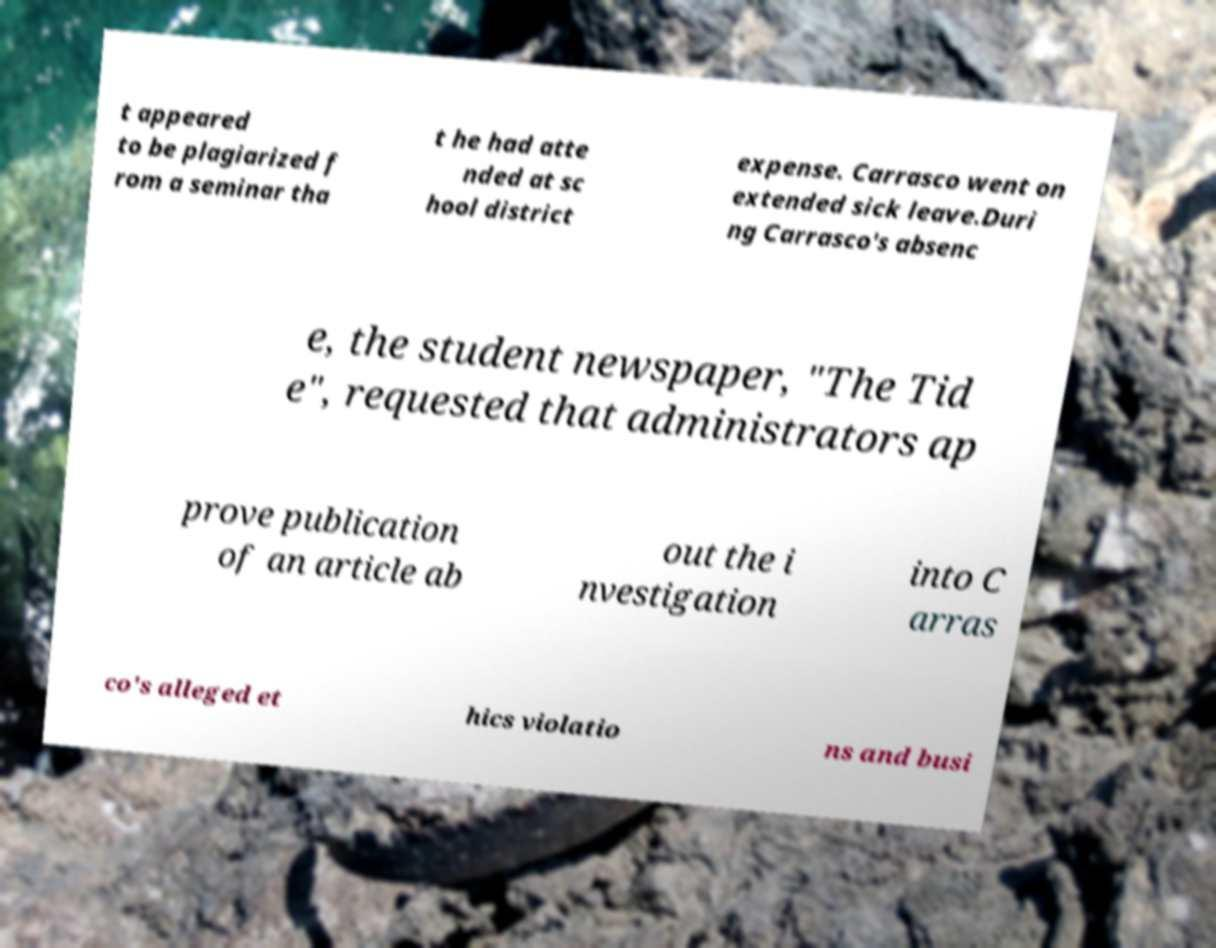Please identify and transcribe the text found in this image. t appeared to be plagiarized f rom a seminar tha t he had atte nded at sc hool district expense. Carrasco went on extended sick leave.Duri ng Carrasco's absenc e, the student newspaper, "The Tid e", requested that administrators ap prove publication of an article ab out the i nvestigation into C arras co's alleged et hics violatio ns and busi 